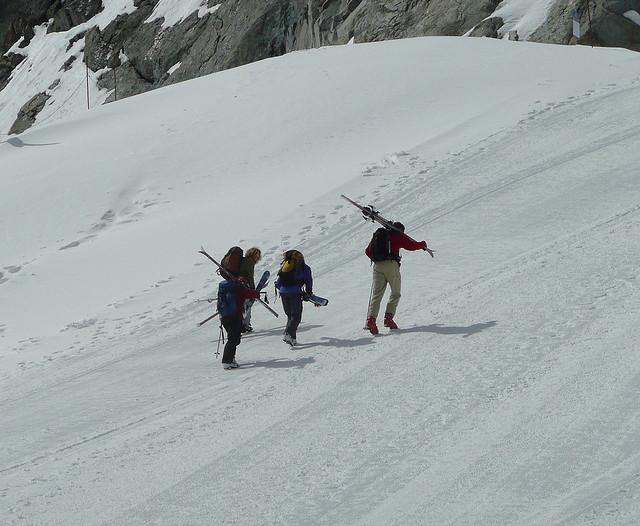Are the people going down a slope?
Give a very brief answer. No. Is the person going slow?
Quick response, please. Yes. Why is the man wearing a helmet?
Short answer required. Skiing. How many people are there?
Quick response, please. 4. Is this an Olympic sport?
Concise answer only. Yes. What is the lady in the foreground doing?
Keep it brief. Walking. What is the caring?
Give a very brief answer. Skis. Where are the men?
Short answer required. Mountain. Is the person going uphill or downhill?
Answer briefly. Uphill. Are they skiing?
Answer briefly. Yes. Of these 5 people, how many people are on skis and how many on snowboards?
Be succinct. 0. 